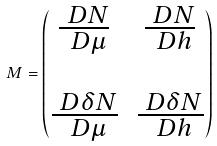Convert formula to latex. <formula><loc_0><loc_0><loc_500><loc_500>M = \begin{pmatrix} \frac { \ D N } { \ D \mu } & \frac { \ D N } { \ D h } \\ \\ \frac { \ D \delta N } { \ D \mu } & \frac { \ D \delta N } { \ D h } \end{pmatrix}</formula> 